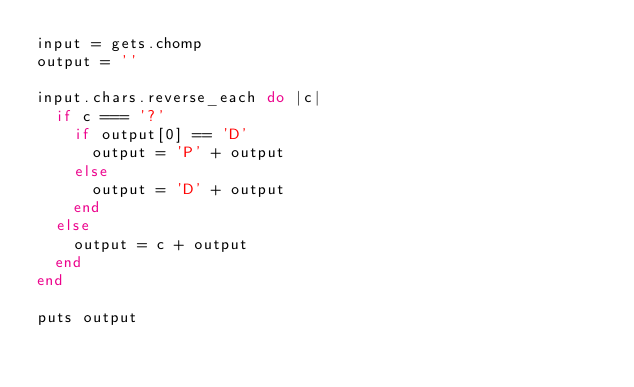Convert code to text. <code><loc_0><loc_0><loc_500><loc_500><_Ruby_>input = gets.chomp
output = ''

input.chars.reverse_each do |c|
	if c === '?'
		if output[0] == 'D'
			output = 'P' + output
		else
			output = 'D' + output
		end
	else
		output = c + output
	end
end

puts output</code> 